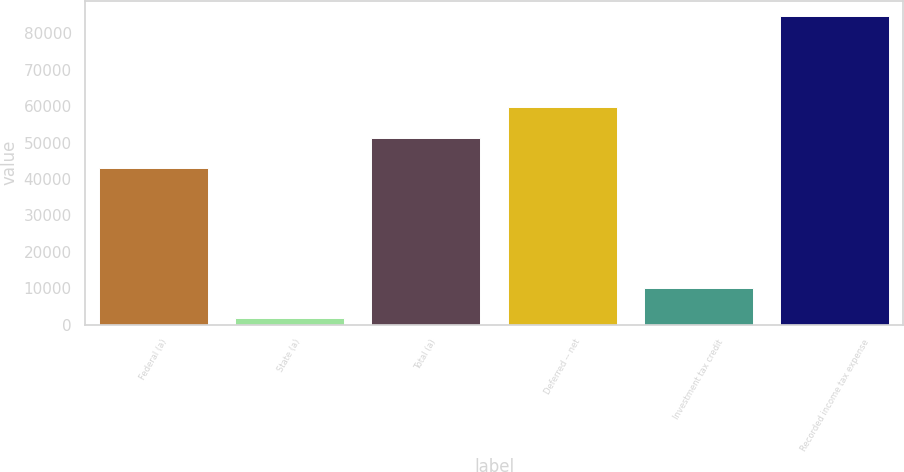Convert chart. <chart><loc_0><loc_0><loc_500><loc_500><bar_chart><fcel>Federal (a)<fcel>State (a)<fcel>Total (a)<fcel>Deferred -- net<fcel>Investment tax credit<fcel>Recorded income tax expense<nl><fcel>43048<fcel>1867<fcel>51337.8<fcel>59627.6<fcel>10156.8<fcel>84765<nl></chart> 